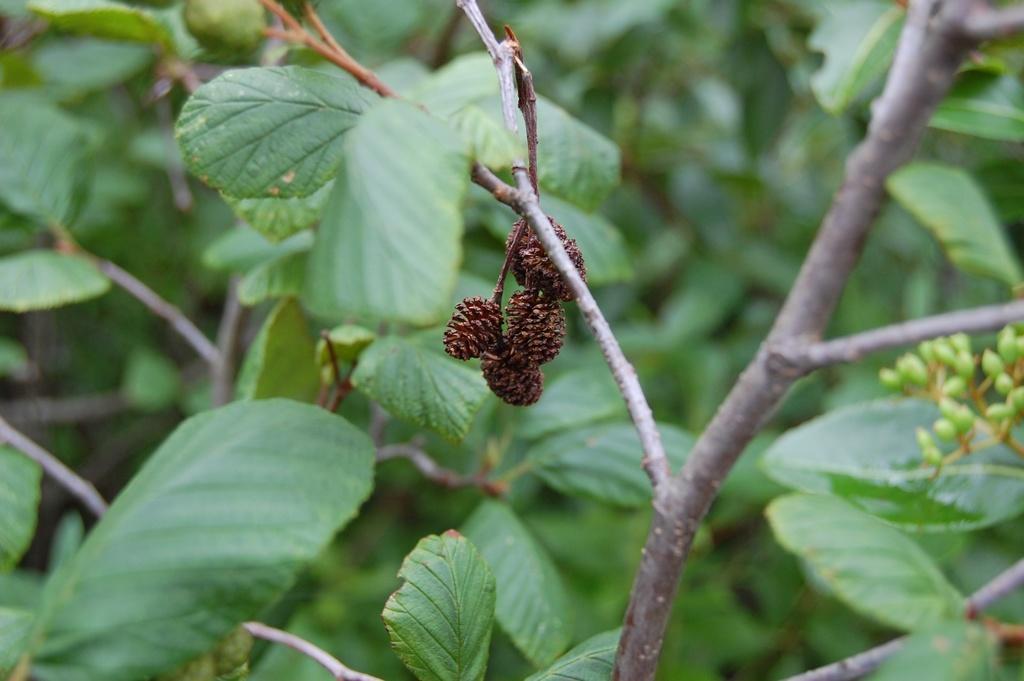Can you describe this image briefly? In this image there are plants and in the center there is a fruit which is hanging. 